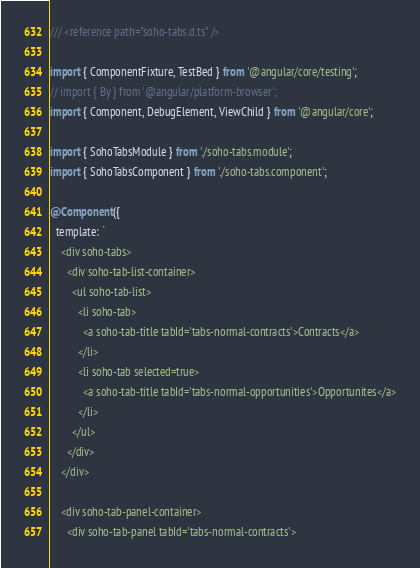<code> <loc_0><loc_0><loc_500><loc_500><_TypeScript_>/// <reference path="soho-tabs.d.ts" />

import { ComponentFixture, TestBed } from '@angular/core/testing';
// import { By } from '@angular/platform-browser';
import { Component, DebugElement, ViewChild } from '@angular/core';

import { SohoTabsModule } from './soho-tabs.module';
import { SohoTabsComponent } from './soho-tabs.component';

@Component({
  template: `
    <div soho-tabs>
      <div soho-tab-list-container>
        <ul soho-tab-list>
          <li soho-tab>
            <a soho-tab-title tabId='tabs-normal-contracts'>Contracts</a>
          </li>
          <li soho-tab selected=true>
            <a soho-tab-title tabId='tabs-normal-opportunities'>Opportunites</a>
          </li>
        </ul>
      </div>
    </div>

    <div soho-tab-panel-container>
      <div soho-tab-panel tabId='tabs-normal-contracts'></code> 